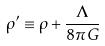<formula> <loc_0><loc_0><loc_500><loc_500>\rho ^ { \prime } \equiv \rho + \frac { \Lambda } { 8 \pi G }</formula> 